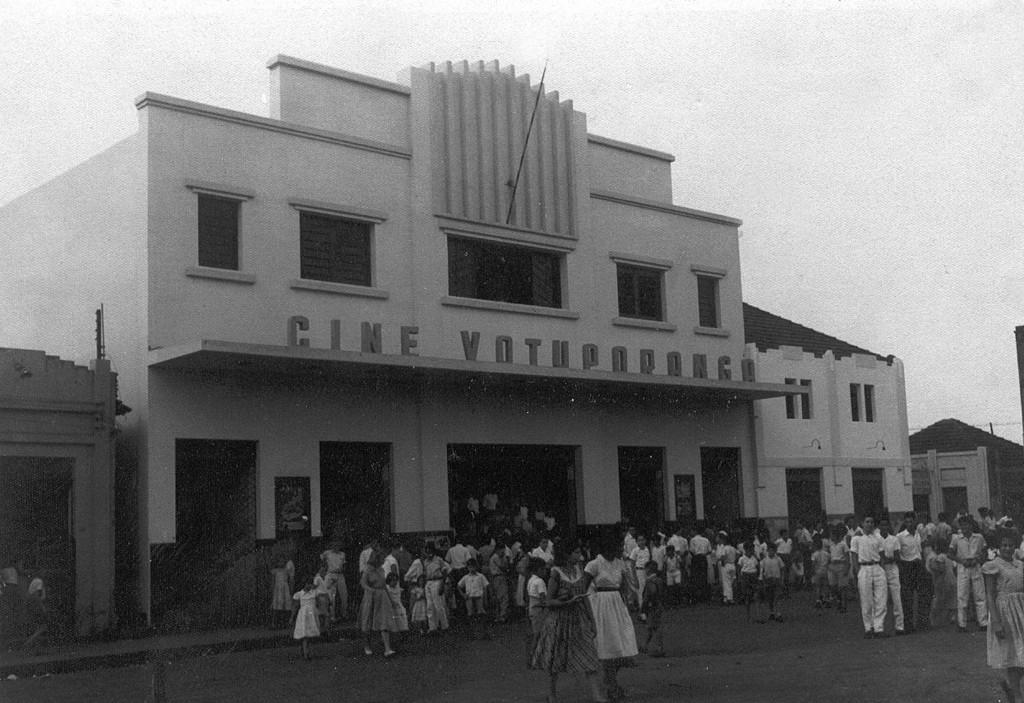Please provide a concise description of this image. In this image in the center there are some buildings and at the bottom there are some children who are walking, and some of them are standing. On the top of the image there is sky. 